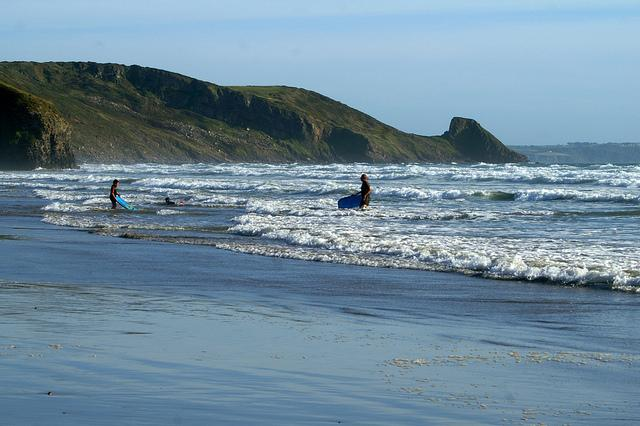What animal can usually be found here? fish 